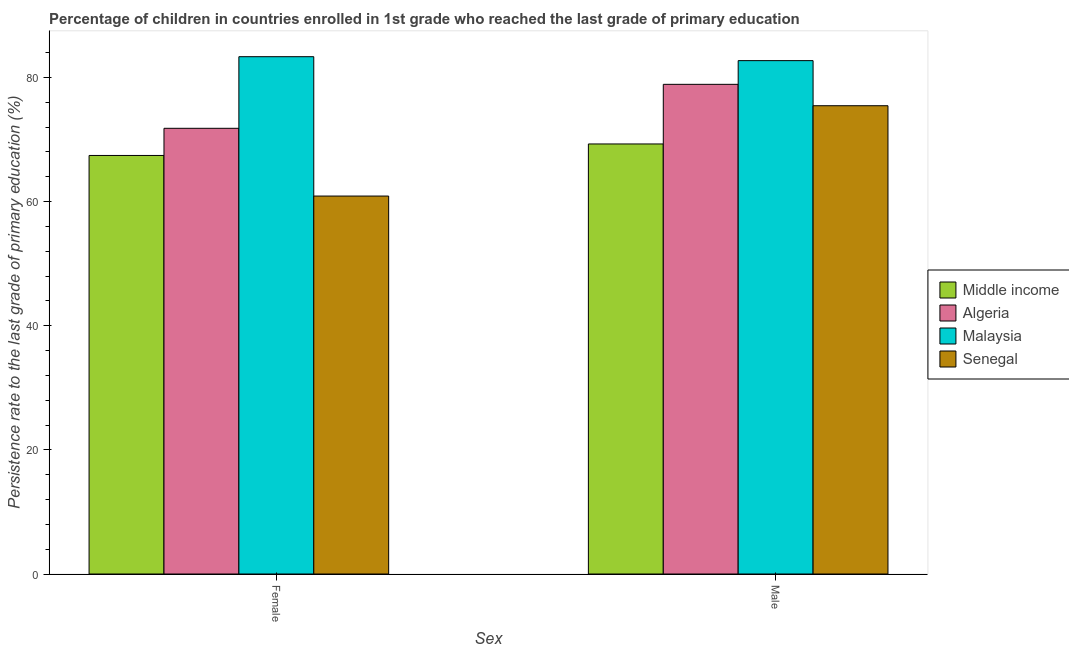How many different coloured bars are there?
Ensure brevity in your answer.  4. How many groups of bars are there?
Your answer should be compact. 2. Are the number of bars per tick equal to the number of legend labels?
Your answer should be compact. Yes. What is the persistence rate of male students in Middle income?
Offer a terse response. 69.29. Across all countries, what is the maximum persistence rate of male students?
Your answer should be compact. 82.71. Across all countries, what is the minimum persistence rate of female students?
Offer a very short reply. 60.89. In which country was the persistence rate of female students maximum?
Your answer should be very brief. Malaysia. In which country was the persistence rate of female students minimum?
Provide a short and direct response. Senegal. What is the total persistence rate of male students in the graph?
Provide a succinct answer. 306.33. What is the difference between the persistence rate of male students in Algeria and that in Senegal?
Offer a terse response. 3.45. What is the difference between the persistence rate of male students in Senegal and the persistence rate of female students in Malaysia?
Provide a short and direct response. -7.9. What is the average persistence rate of female students per country?
Ensure brevity in your answer.  70.87. What is the difference between the persistence rate of female students and persistence rate of male students in Malaysia?
Make the answer very short. 0.63. What is the ratio of the persistence rate of female students in Malaysia to that in Middle income?
Make the answer very short. 1.24. Is the persistence rate of female students in Senegal less than that in Malaysia?
Your response must be concise. Yes. In how many countries, is the persistence rate of female students greater than the average persistence rate of female students taken over all countries?
Offer a terse response. 2. What does the 1st bar from the left in Male represents?
Provide a short and direct response. Middle income. What does the 1st bar from the right in Male represents?
Provide a succinct answer. Senegal. How many bars are there?
Provide a short and direct response. 8. Are all the bars in the graph horizontal?
Ensure brevity in your answer.  No. How many countries are there in the graph?
Give a very brief answer. 4. What is the difference between two consecutive major ticks on the Y-axis?
Your answer should be very brief. 20. Does the graph contain any zero values?
Offer a terse response. No. Does the graph contain grids?
Offer a very short reply. No. How are the legend labels stacked?
Ensure brevity in your answer.  Vertical. What is the title of the graph?
Keep it short and to the point. Percentage of children in countries enrolled in 1st grade who reached the last grade of primary education. Does "Somalia" appear as one of the legend labels in the graph?
Your response must be concise. No. What is the label or title of the X-axis?
Keep it short and to the point. Sex. What is the label or title of the Y-axis?
Provide a succinct answer. Persistence rate to the last grade of primary education (%). What is the Persistence rate to the last grade of primary education (%) in Middle income in Female?
Your response must be concise. 67.43. What is the Persistence rate to the last grade of primary education (%) of Algeria in Female?
Provide a succinct answer. 71.81. What is the Persistence rate to the last grade of primary education (%) in Malaysia in Female?
Your answer should be very brief. 83.35. What is the Persistence rate to the last grade of primary education (%) of Senegal in Female?
Offer a terse response. 60.89. What is the Persistence rate to the last grade of primary education (%) in Middle income in Male?
Offer a terse response. 69.29. What is the Persistence rate to the last grade of primary education (%) in Algeria in Male?
Your response must be concise. 78.89. What is the Persistence rate to the last grade of primary education (%) of Malaysia in Male?
Make the answer very short. 82.71. What is the Persistence rate to the last grade of primary education (%) in Senegal in Male?
Your answer should be compact. 75.45. Across all Sex, what is the maximum Persistence rate to the last grade of primary education (%) of Middle income?
Ensure brevity in your answer.  69.29. Across all Sex, what is the maximum Persistence rate to the last grade of primary education (%) of Algeria?
Keep it short and to the point. 78.89. Across all Sex, what is the maximum Persistence rate to the last grade of primary education (%) of Malaysia?
Give a very brief answer. 83.35. Across all Sex, what is the maximum Persistence rate to the last grade of primary education (%) of Senegal?
Provide a short and direct response. 75.45. Across all Sex, what is the minimum Persistence rate to the last grade of primary education (%) of Middle income?
Provide a short and direct response. 67.43. Across all Sex, what is the minimum Persistence rate to the last grade of primary education (%) of Algeria?
Your answer should be compact. 71.81. Across all Sex, what is the minimum Persistence rate to the last grade of primary education (%) of Malaysia?
Offer a very short reply. 82.71. Across all Sex, what is the minimum Persistence rate to the last grade of primary education (%) in Senegal?
Keep it short and to the point. 60.89. What is the total Persistence rate to the last grade of primary education (%) of Middle income in the graph?
Make the answer very short. 136.72. What is the total Persistence rate to the last grade of primary education (%) of Algeria in the graph?
Ensure brevity in your answer.  150.7. What is the total Persistence rate to the last grade of primary education (%) of Malaysia in the graph?
Make the answer very short. 166.06. What is the total Persistence rate to the last grade of primary education (%) of Senegal in the graph?
Your answer should be compact. 136.34. What is the difference between the Persistence rate to the last grade of primary education (%) of Middle income in Female and that in Male?
Your answer should be very brief. -1.85. What is the difference between the Persistence rate to the last grade of primary education (%) of Algeria in Female and that in Male?
Your response must be concise. -7.08. What is the difference between the Persistence rate to the last grade of primary education (%) of Malaysia in Female and that in Male?
Your answer should be very brief. 0.63. What is the difference between the Persistence rate to the last grade of primary education (%) in Senegal in Female and that in Male?
Provide a succinct answer. -14.55. What is the difference between the Persistence rate to the last grade of primary education (%) of Middle income in Female and the Persistence rate to the last grade of primary education (%) of Algeria in Male?
Give a very brief answer. -11.46. What is the difference between the Persistence rate to the last grade of primary education (%) in Middle income in Female and the Persistence rate to the last grade of primary education (%) in Malaysia in Male?
Keep it short and to the point. -15.28. What is the difference between the Persistence rate to the last grade of primary education (%) of Middle income in Female and the Persistence rate to the last grade of primary education (%) of Senegal in Male?
Your response must be concise. -8.01. What is the difference between the Persistence rate to the last grade of primary education (%) in Algeria in Female and the Persistence rate to the last grade of primary education (%) in Malaysia in Male?
Ensure brevity in your answer.  -10.9. What is the difference between the Persistence rate to the last grade of primary education (%) of Algeria in Female and the Persistence rate to the last grade of primary education (%) of Senegal in Male?
Give a very brief answer. -3.64. What is the difference between the Persistence rate to the last grade of primary education (%) of Malaysia in Female and the Persistence rate to the last grade of primary education (%) of Senegal in Male?
Make the answer very short. 7.9. What is the average Persistence rate to the last grade of primary education (%) of Middle income per Sex?
Offer a terse response. 68.36. What is the average Persistence rate to the last grade of primary education (%) of Algeria per Sex?
Offer a terse response. 75.35. What is the average Persistence rate to the last grade of primary education (%) in Malaysia per Sex?
Provide a succinct answer. 83.03. What is the average Persistence rate to the last grade of primary education (%) of Senegal per Sex?
Your answer should be compact. 68.17. What is the difference between the Persistence rate to the last grade of primary education (%) of Middle income and Persistence rate to the last grade of primary education (%) of Algeria in Female?
Offer a very short reply. -4.38. What is the difference between the Persistence rate to the last grade of primary education (%) of Middle income and Persistence rate to the last grade of primary education (%) of Malaysia in Female?
Give a very brief answer. -15.91. What is the difference between the Persistence rate to the last grade of primary education (%) of Middle income and Persistence rate to the last grade of primary education (%) of Senegal in Female?
Provide a short and direct response. 6.54. What is the difference between the Persistence rate to the last grade of primary education (%) in Algeria and Persistence rate to the last grade of primary education (%) in Malaysia in Female?
Your answer should be very brief. -11.54. What is the difference between the Persistence rate to the last grade of primary education (%) in Algeria and Persistence rate to the last grade of primary education (%) in Senegal in Female?
Give a very brief answer. 10.92. What is the difference between the Persistence rate to the last grade of primary education (%) in Malaysia and Persistence rate to the last grade of primary education (%) in Senegal in Female?
Offer a terse response. 22.45. What is the difference between the Persistence rate to the last grade of primary education (%) of Middle income and Persistence rate to the last grade of primary education (%) of Algeria in Male?
Your answer should be compact. -9.61. What is the difference between the Persistence rate to the last grade of primary education (%) in Middle income and Persistence rate to the last grade of primary education (%) in Malaysia in Male?
Keep it short and to the point. -13.43. What is the difference between the Persistence rate to the last grade of primary education (%) of Middle income and Persistence rate to the last grade of primary education (%) of Senegal in Male?
Keep it short and to the point. -6.16. What is the difference between the Persistence rate to the last grade of primary education (%) in Algeria and Persistence rate to the last grade of primary education (%) in Malaysia in Male?
Give a very brief answer. -3.82. What is the difference between the Persistence rate to the last grade of primary education (%) of Algeria and Persistence rate to the last grade of primary education (%) of Senegal in Male?
Offer a very short reply. 3.45. What is the difference between the Persistence rate to the last grade of primary education (%) in Malaysia and Persistence rate to the last grade of primary education (%) in Senegal in Male?
Your response must be concise. 7.27. What is the ratio of the Persistence rate to the last grade of primary education (%) in Middle income in Female to that in Male?
Your answer should be compact. 0.97. What is the ratio of the Persistence rate to the last grade of primary education (%) in Algeria in Female to that in Male?
Ensure brevity in your answer.  0.91. What is the ratio of the Persistence rate to the last grade of primary education (%) in Malaysia in Female to that in Male?
Provide a succinct answer. 1.01. What is the ratio of the Persistence rate to the last grade of primary education (%) in Senegal in Female to that in Male?
Your answer should be very brief. 0.81. What is the difference between the highest and the second highest Persistence rate to the last grade of primary education (%) in Middle income?
Your answer should be compact. 1.85. What is the difference between the highest and the second highest Persistence rate to the last grade of primary education (%) of Algeria?
Your answer should be compact. 7.08. What is the difference between the highest and the second highest Persistence rate to the last grade of primary education (%) in Malaysia?
Offer a terse response. 0.63. What is the difference between the highest and the second highest Persistence rate to the last grade of primary education (%) in Senegal?
Your response must be concise. 14.55. What is the difference between the highest and the lowest Persistence rate to the last grade of primary education (%) of Middle income?
Offer a terse response. 1.85. What is the difference between the highest and the lowest Persistence rate to the last grade of primary education (%) in Algeria?
Offer a very short reply. 7.08. What is the difference between the highest and the lowest Persistence rate to the last grade of primary education (%) in Malaysia?
Your answer should be very brief. 0.63. What is the difference between the highest and the lowest Persistence rate to the last grade of primary education (%) of Senegal?
Your response must be concise. 14.55. 